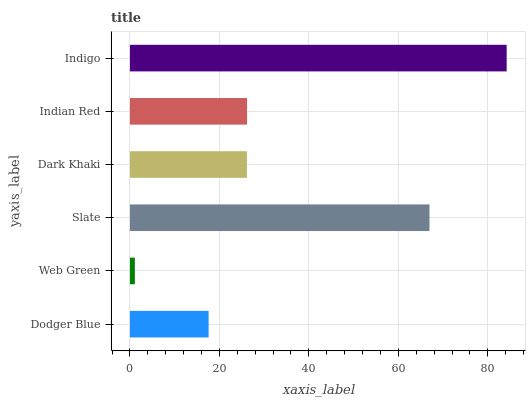Is Web Green the minimum?
Answer yes or no. Yes. Is Indigo the maximum?
Answer yes or no. Yes. Is Slate the minimum?
Answer yes or no. No. Is Slate the maximum?
Answer yes or no. No. Is Slate greater than Web Green?
Answer yes or no. Yes. Is Web Green less than Slate?
Answer yes or no. Yes. Is Web Green greater than Slate?
Answer yes or no. No. Is Slate less than Web Green?
Answer yes or no. No. Is Indian Red the high median?
Answer yes or no. Yes. Is Dark Khaki the low median?
Answer yes or no. Yes. Is Indigo the high median?
Answer yes or no. No. Is Indigo the low median?
Answer yes or no. No. 